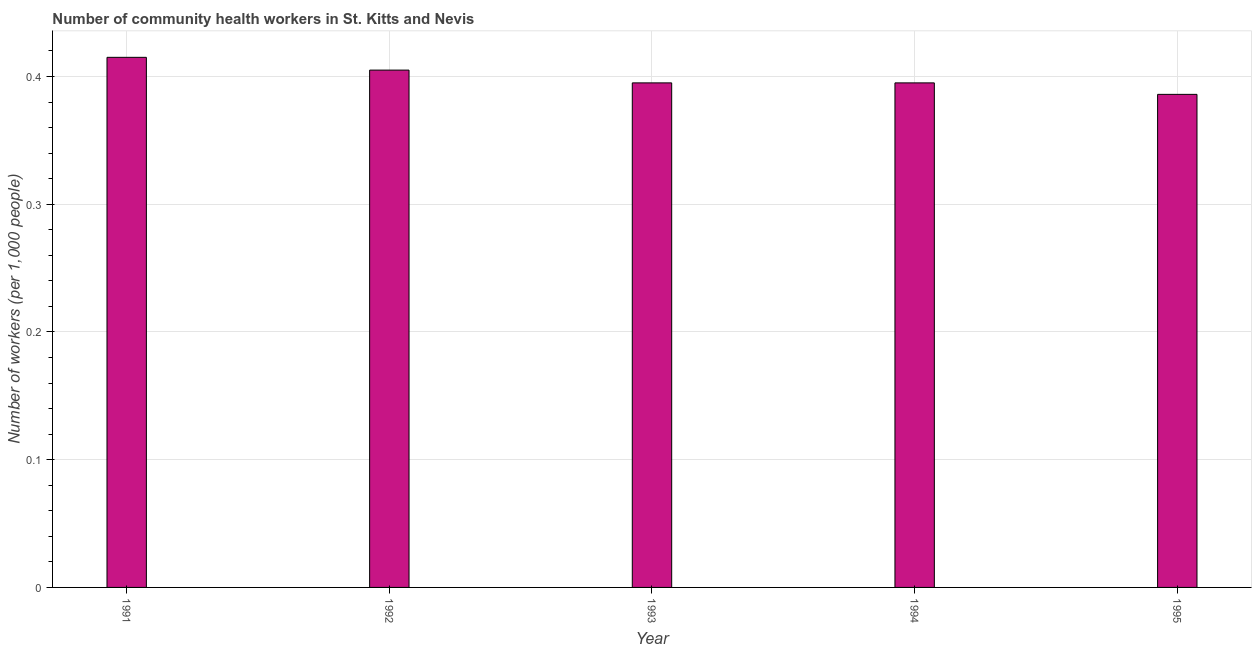Does the graph contain grids?
Provide a succinct answer. Yes. What is the title of the graph?
Keep it short and to the point. Number of community health workers in St. Kitts and Nevis. What is the label or title of the Y-axis?
Your response must be concise. Number of workers (per 1,0 people). What is the number of community health workers in 1992?
Provide a succinct answer. 0.41. Across all years, what is the maximum number of community health workers?
Offer a very short reply. 0.41. Across all years, what is the minimum number of community health workers?
Your answer should be very brief. 0.39. What is the sum of the number of community health workers?
Offer a very short reply. 2. What is the average number of community health workers per year?
Offer a terse response. 0.4. What is the median number of community health workers?
Provide a succinct answer. 0.4. In how many years, is the number of community health workers greater than 0.38 ?
Provide a succinct answer. 5. Do a majority of the years between 1991 and 1993 (inclusive) have number of community health workers greater than 0.06 ?
Your answer should be compact. Yes. What is the ratio of the number of community health workers in 1992 to that in 1994?
Your answer should be compact. 1.02. Is the number of community health workers in 1991 less than that in 1995?
Keep it short and to the point. No. Is the difference between the number of community health workers in 1992 and 1995 greater than the difference between any two years?
Offer a terse response. No. What is the difference between the highest and the second highest number of community health workers?
Your answer should be compact. 0.01. What is the difference between the highest and the lowest number of community health workers?
Give a very brief answer. 0.03. In how many years, is the number of community health workers greater than the average number of community health workers taken over all years?
Your answer should be very brief. 2. How many bars are there?
Give a very brief answer. 5. How many years are there in the graph?
Ensure brevity in your answer.  5. What is the difference between two consecutive major ticks on the Y-axis?
Give a very brief answer. 0.1. What is the Number of workers (per 1,000 people) of 1991?
Your response must be concise. 0.41. What is the Number of workers (per 1,000 people) of 1992?
Give a very brief answer. 0.41. What is the Number of workers (per 1,000 people) in 1993?
Offer a terse response. 0.4. What is the Number of workers (per 1,000 people) of 1994?
Provide a short and direct response. 0.4. What is the Number of workers (per 1,000 people) of 1995?
Ensure brevity in your answer.  0.39. What is the difference between the Number of workers (per 1,000 people) in 1991 and 1992?
Provide a succinct answer. 0.01. What is the difference between the Number of workers (per 1,000 people) in 1991 and 1995?
Give a very brief answer. 0.03. What is the difference between the Number of workers (per 1,000 people) in 1992 and 1993?
Your answer should be very brief. 0.01. What is the difference between the Number of workers (per 1,000 people) in 1992 and 1995?
Keep it short and to the point. 0.02. What is the difference between the Number of workers (per 1,000 people) in 1993 and 1994?
Give a very brief answer. 0. What is the difference between the Number of workers (per 1,000 people) in 1993 and 1995?
Make the answer very short. 0.01. What is the difference between the Number of workers (per 1,000 people) in 1994 and 1995?
Keep it short and to the point. 0.01. What is the ratio of the Number of workers (per 1,000 people) in 1991 to that in 1992?
Offer a very short reply. 1.02. What is the ratio of the Number of workers (per 1,000 people) in 1991 to that in 1993?
Make the answer very short. 1.05. What is the ratio of the Number of workers (per 1,000 people) in 1991 to that in 1994?
Offer a terse response. 1.05. What is the ratio of the Number of workers (per 1,000 people) in 1991 to that in 1995?
Offer a terse response. 1.07. What is the ratio of the Number of workers (per 1,000 people) in 1992 to that in 1993?
Your answer should be very brief. 1.02. What is the ratio of the Number of workers (per 1,000 people) in 1992 to that in 1994?
Ensure brevity in your answer.  1.02. What is the ratio of the Number of workers (per 1,000 people) in 1992 to that in 1995?
Your response must be concise. 1.05. What is the ratio of the Number of workers (per 1,000 people) in 1993 to that in 1994?
Provide a short and direct response. 1. What is the ratio of the Number of workers (per 1,000 people) in 1994 to that in 1995?
Offer a very short reply. 1.02. 